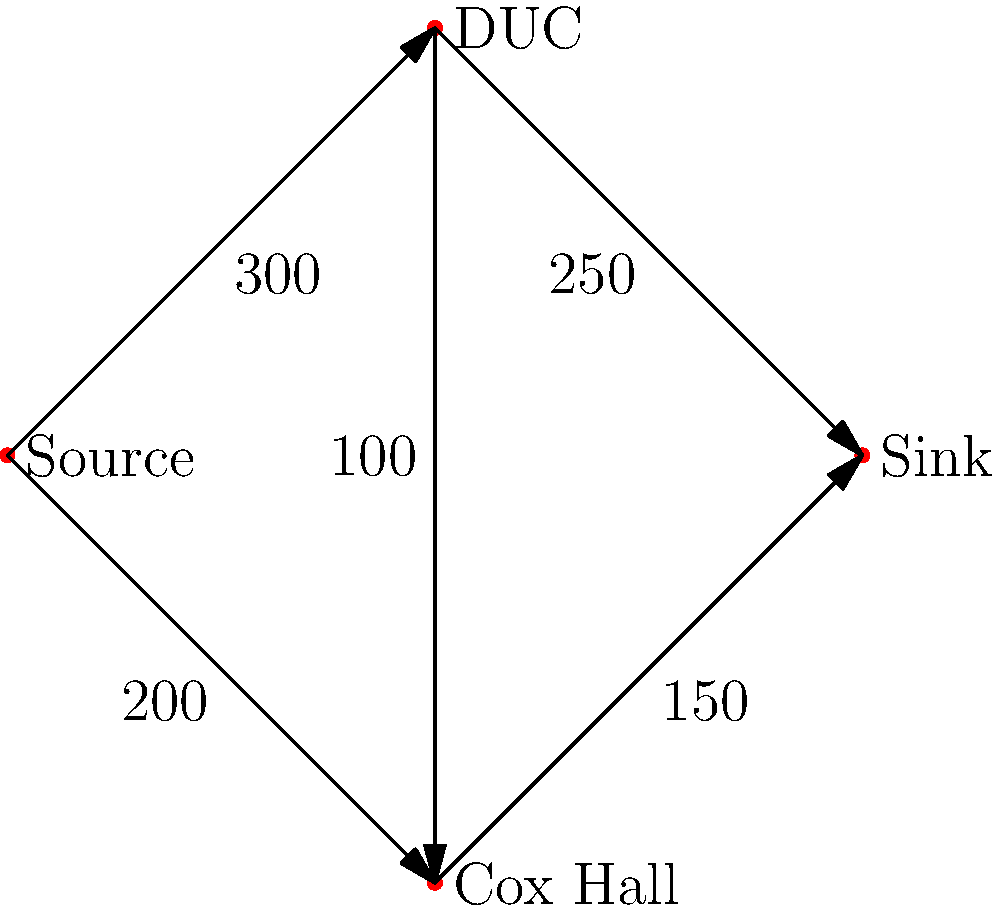Your grandfather, an Emory alumnus, tells you about the university's dining system. He explains that during peak hours, students flow from classes to two main dining halls: the Dobbs University Center (DUC) and Cox Hall. Using the maximum flow algorithm on the given network, where the numbers represent the maximum number of students that can pass through each path per hour, what is the maximum number of students that can be served in the dining halls during peak hours? To solve this maximum flow problem, we'll use the Ford-Fulkerson algorithm:

1) Initialize flow to 0 for all edges.

2) Find augmenting paths from source to sink:

   Path 1: Source → DUC → Sink (min capacity: 250)
   Flow becomes: 
   Source → DUC: 250
   DUC → Sink: 250

   Path 2: Source → Cox Hall → Sink (min capacity: 150)
   Flow becomes:
   Source → Cox Hall: 150
   Cox Hall → Sink: 150

   Path 3: Source → DUC → Cox Hall → Sink (min capacity: 50)
   Flow becomes:
   Source → DUC: 300
   DUC → Cox Hall: 50
   Cox Hall → Sink: 200

3) No more augmenting paths exist.

4) Sum the flows into the sink:
   DUC → Sink: 250
   Cox Hall → Sink: 200

5) Total maximum flow = 250 + 200 = 450
Answer: 450 students per hour 